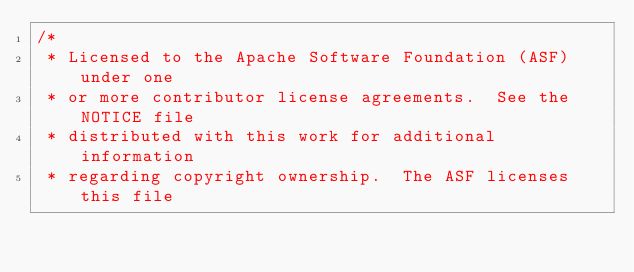<code> <loc_0><loc_0><loc_500><loc_500><_C#_>/*
 * Licensed to the Apache Software Foundation (ASF) under one
 * or more contributor license agreements.  See the NOTICE file
 * distributed with this work for additional information
 * regarding copyright ownership.  The ASF licenses this file</code> 